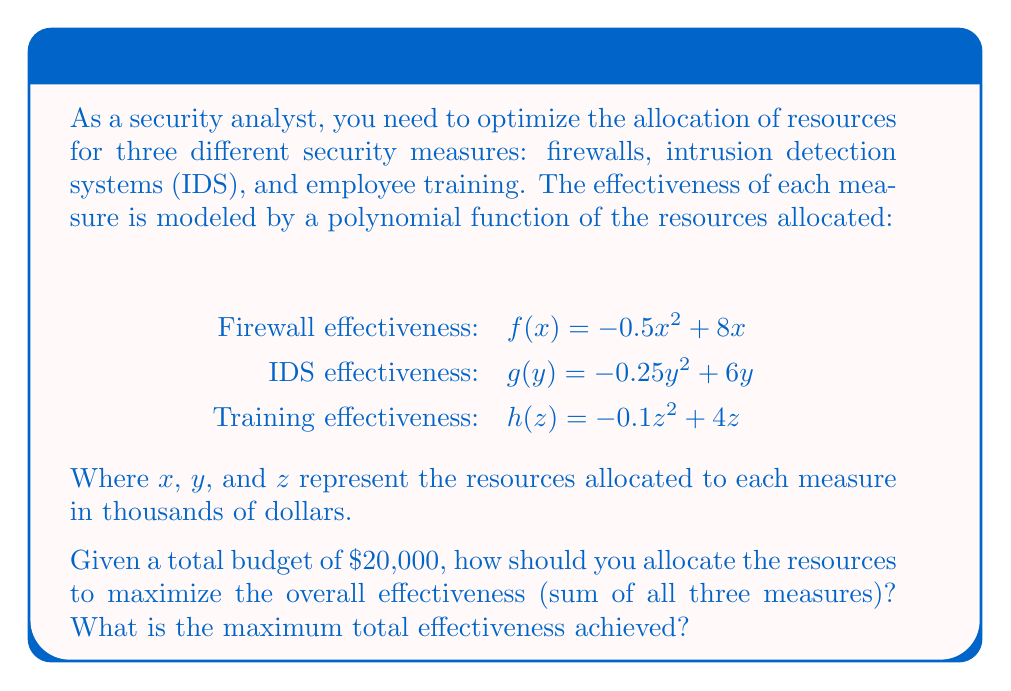What is the answer to this math problem? To solve this optimization problem, we need to use the method of Lagrange multipliers, as we have a constraint (total budget) and want to maximize a function.

1. Let's define our objective function:
   $E(x,y,z) = f(x) + g(y) + h(z) = (-0.5x^2 + 8x) + (-0.25y^2 + 6y) + (-0.1z^2 + 4z)$

2. Our constraint is:
   $x + y + z = 20$ (since the budget is $20,000)

3. Form the Lagrangian:
   $L(x,y,z,λ) = E(x,y,z) - λ(x + y + z - 20)$

4. Take partial derivatives and set them to zero:
   $\frac{\partial L}{\partial x} = -x + 8 - λ = 0$
   $\frac{\partial L}{\partial y} = -0.5y + 6 - λ = 0$
   $\frac{\partial L}{\partial z} = -0.2z + 4 - λ = 0$
   $\frac{\partial L}{\partial λ} = x + y + z - 20 = 0$

5. Solve the system of equations:
   From the first three equations:
   $x = 8 - λ$
   $y = 12 - 2λ$
   $z = 20 - 5λ$

   Substitute these into the fourth equation:
   $(8 - λ) + (12 - 2λ) + (20 - 5λ) = 20$
   $40 - 8λ = 20$
   $20 = 8λ$
   $λ = 2.5$

6. Now we can find x, y, and z:
   $x = 8 - 2.5 = 5.5$
   $y = 12 - 2(2.5) = 7$
   $z = 20 - 5(2.5) = 7.5$

7. Calculate the maximum effectiveness:
   $E(5.5, 7, 7.5) = (-0.5(5.5)^2 + 8(5.5)) + (-0.25(7)^2 + 6(7)) + (-0.1(7.5)^2 + 4(7.5))$
   $= (29.375) + (29.75) + (22.875)$
   $= 82$
Answer: Optimal resource allocation: $5,500 for firewalls, $7,000 for IDS, and $7,500 for employee training. The maximum total effectiveness achieved is 82 units. 